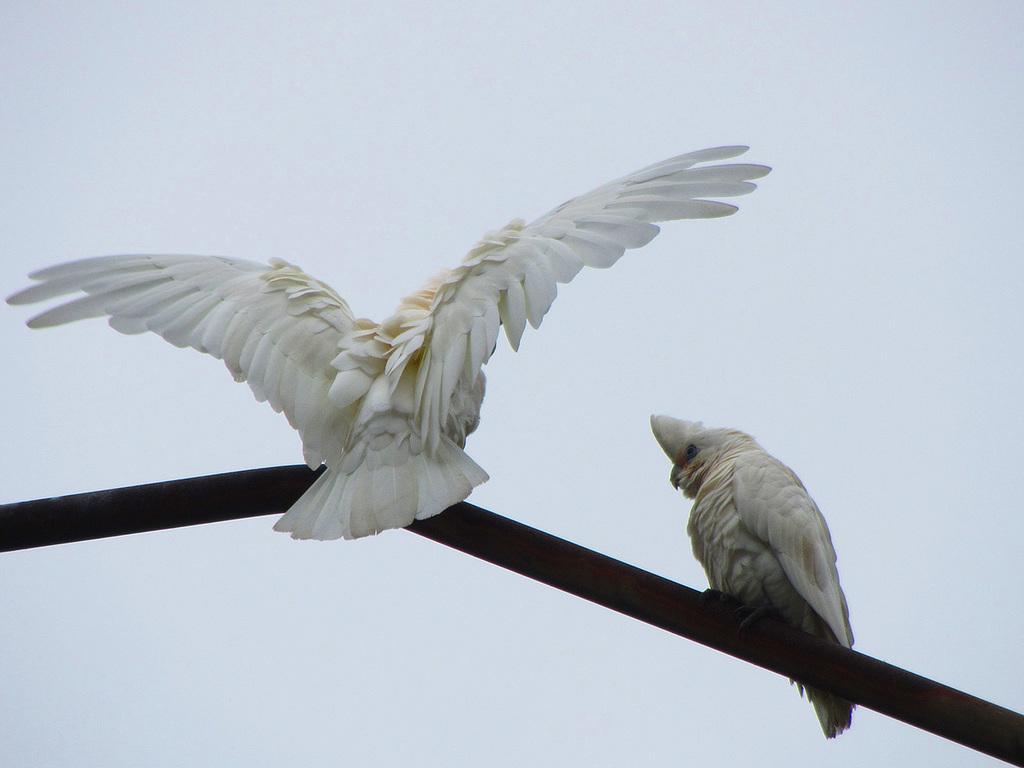Please provide a concise description of this image. There are two white color birds standing on a road. One of them is stretching its wings. In the background, there is sky. 